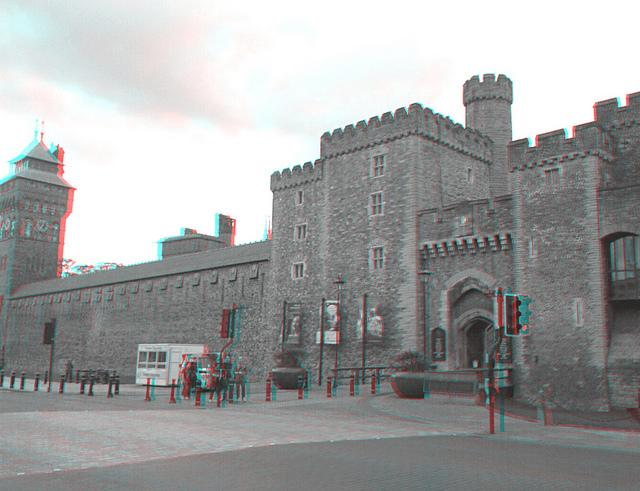What instance of building is shown in the image? Please explain your reasoning. tourist spot. This is a tourist castle. 